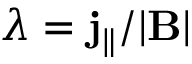<formula> <loc_0><loc_0><loc_500><loc_500>\lambda = j _ { \| } / | B |</formula> 